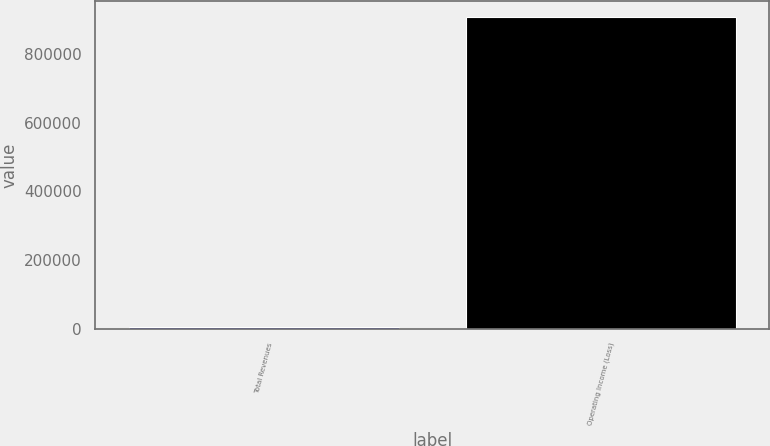<chart> <loc_0><loc_0><loc_500><loc_500><bar_chart><fcel>Total Revenues<fcel>Operating Income (Loss)<nl><fcel>4609<fcel>910109<nl></chart> 